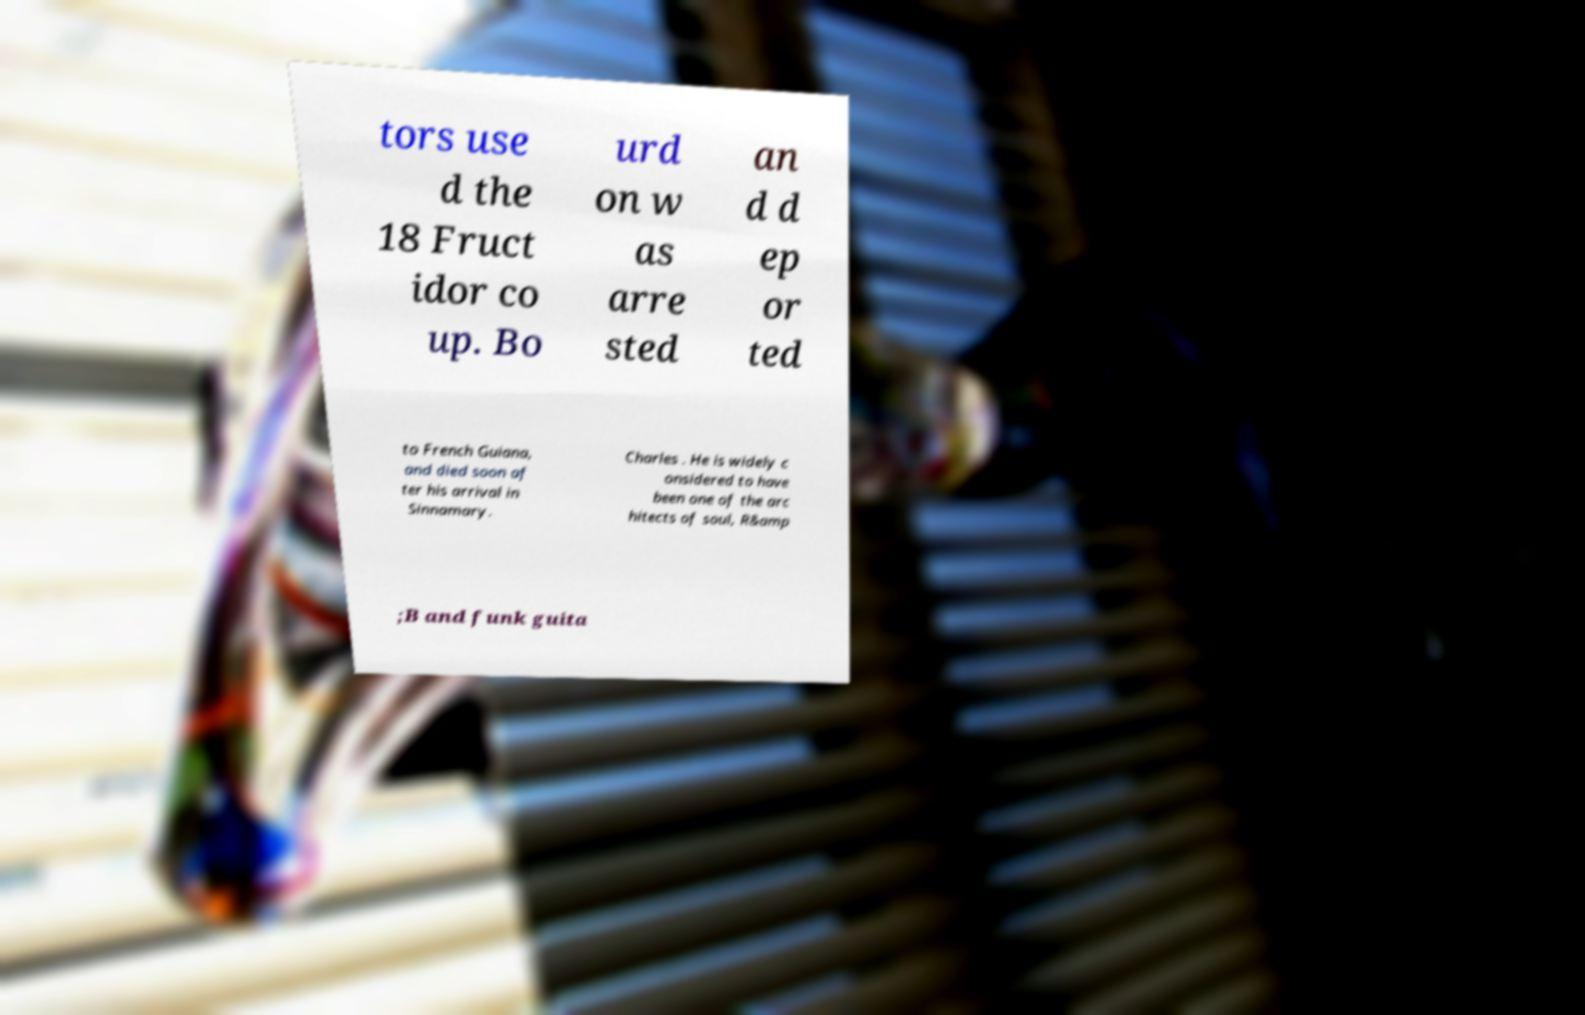Please read and relay the text visible in this image. What does it say? tors use d the 18 Fruct idor co up. Bo urd on w as arre sted an d d ep or ted to French Guiana, and died soon af ter his arrival in Sinnamary. Charles . He is widely c onsidered to have been one of the arc hitects of soul, R&amp ;B and funk guita 